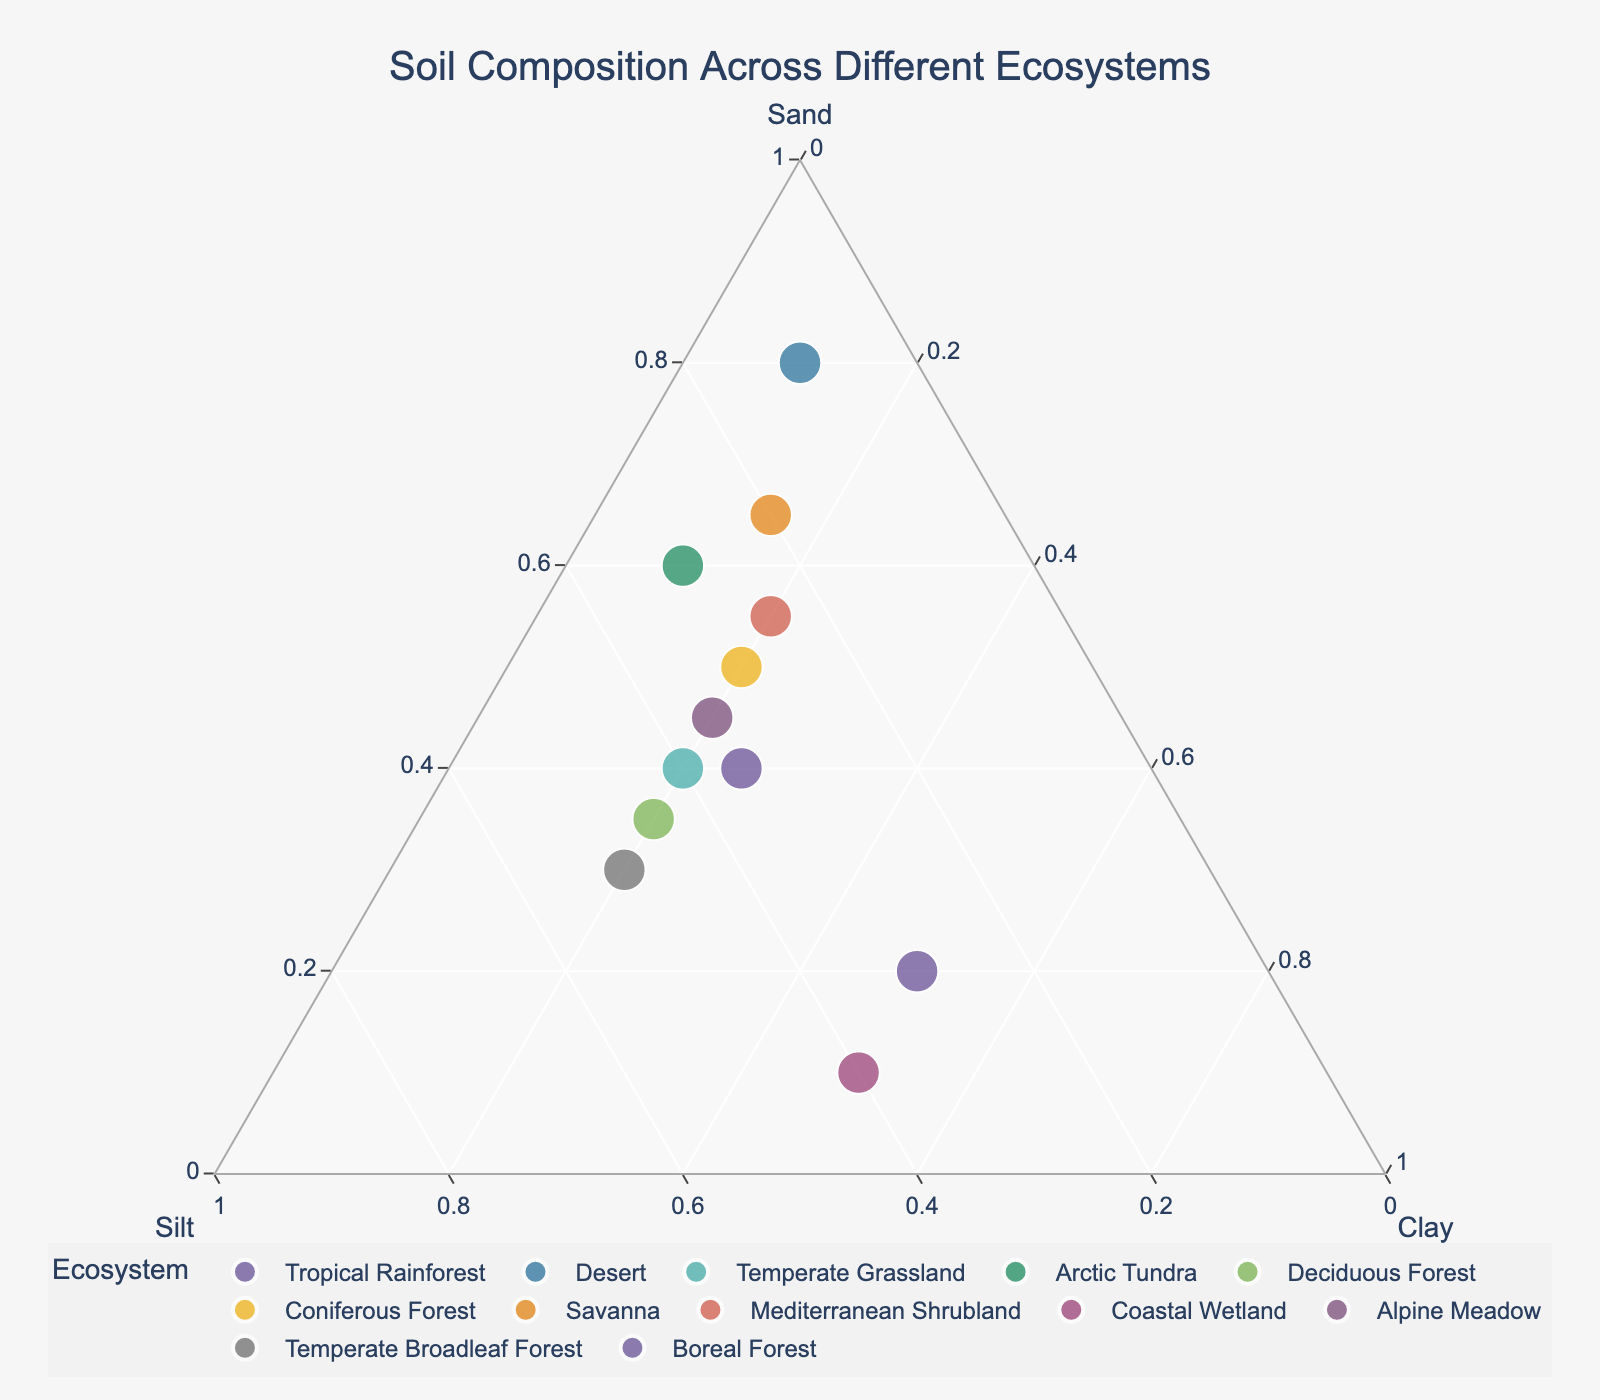what is the soil composition of the Desert ecosystem? Look for the point labeled "Desert" in the Ternary Plot. Check its hover data to get the exact percentages of sand, silt, and clay. The Desert point shows 80% Sand, 10% Silt, and 10% Clay.
Answer: 80% Sand, 10% Silt, 10% Clay Which ecosystem has the highest percentage of silt? Locate the point on the plot that is positioned nearest to the Silt apex. "Temperate Broadleaf Forest" is closest to the Silt apex, indicating it has the highest percentage of silt at 50%.
Answer: Temperate Broadleaf Forest Which two ecosystems have the same amount of clay? Look for points that align horizontally from the Clay axis with the same value. "Tropical Rainforest" and "Coastal Wetland" both have 50% Clay.
Answer: Tropical Rainforest and Coastal Wetland Compare the sand content of the Arctic Tundra and Coniferous Forest ecosystems. Which one has more sand percentage-wise? Identify the "Arctic Tundra" and "Coniferous Forest" in the plot. Arctic Tundra has 60% Sand, while Coniferous Forest has 50% Sand. Therefore, Arctic Tundra has more sand.
Answer: Arctic Tundra Calculate the average sand percentage across the Tropical Rainforest, Savanna, and Coastal Wetland ecosystems. Add the sand percentages of Tropical Rainforest (20%), Savanna (65%), and Coastal Wetland (10%), and then divide by 3. (20 + 65 + 10)/3 = 95/3 = ~31.67%.
Answer: ~31.67% Which ecosystems have a clay content greater than 20%? Locate points where the clay percentage is above the 20% mark on the Clay axis. The ecosystems are Tropical Rainforest (50%), Coastal Wetland (50%), and Boreal Forest (25%).
Answer: Tropical Rainforest, Coastal Wetland, Boreal Forest Which ecosystem in the plot has an equal percentage of silt and clay but different than sand? Find a point where the values of silt and clay are equal, but the sand percentage is different. "Deciduous Forest" meets this requirement with 45% Silt and 45% Clay. The sand content is different at 35%.
Answer: Deciduous Forest 